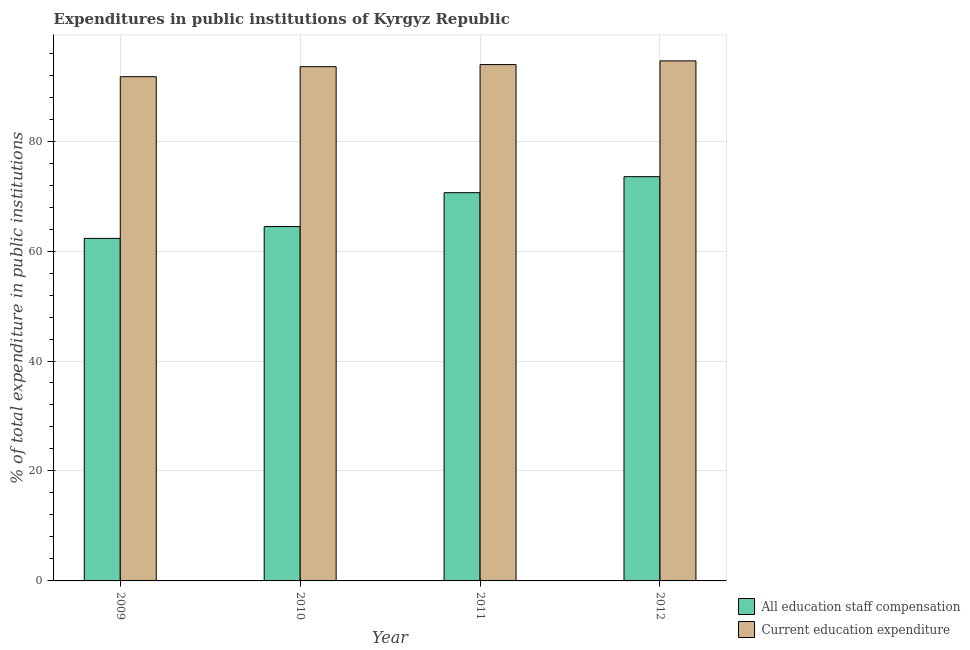How many different coloured bars are there?
Your answer should be compact. 2. Are the number of bars per tick equal to the number of legend labels?
Your answer should be compact. Yes. Are the number of bars on each tick of the X-axis equal?
Your answer should be compact. Yes. How many bars are there on the 2nd tick from the left?
Give a very brief answer. 2. What is the label of the 3rd group of bars from the left?
Offer a very short reply. 2011. What is the expenditure in education in 2010?
Offer a very short reply. 93.53. Across all years, what is the maximum expenditure in staff compensation?
Make the answer very short. 73.53. Across all years, what is the minimum expenditure in education?
Offer a terse response. 91.71. In which year was the expenditure in education maximum?
Give a very brief answer. 2012. What is the total expenditure in education in the graph?
Your answer should be very brief. 373.75. What is the difference between the expenditure in staff compensation in 2009 and that in 2010?
Offer a terse response. -2.15. What is the difference between the expenditure in education in 2011 and the expenditure in staff compensation in 2010?
Your response must be concise. 0.38. What is the average expenditure in education per year?
Provide a short and direct response. 93.44. In the year 2009, what is the difference between the expenditure in staff compensation and expenditure in education?
Keep it short and to the point. 0. In how many years, is the expenditure in education greater than 68 %?
Your answer should be compact. 4. What is the ratio of the expenditure in education in 2010 to that in 2011?
Provide a short and direct response. 1. Is the expenditure in staff compensation in 2009 less than that in 2010?
Make the answer very short. Yes. What is the difference between the highest and the second highest expenditure in staff compensation?
Your response must be concise. 2.91. What is the difference between the highest and the lowest expenditure in staff compensation?
Your response must be concise. 11.22. In how many years, is the expenditure in education greater than the average expenditure in education taken over all years?
Give a very brief answer. 3. Is the sum of the expenditure in education in 2011 and 2012 greater than the maximum expenditure in staff compensation across all years?
Provide a short and direct response. Yes. What does the 1st bar from the left in 2010 represents?
Ensure brevity in your answer.  All education staff compensation. What does the 1st bar from the right in 2009 represents?
Make the answer very short. Current education expenditure. What is the difference between two consecutive major ticks on the Y-axis?
Provide a short and direct response. 20. Does the graph contain grids?
Keep it short and to the point. Yes. How are the legend labels stacked?
Give a very brief answer. Vertical. What is the title of the graph?
Offer a terse response. Expenditures in public institutions of Kyrgyz Republic. Does "Merchandise imports" appear as one of the legend labels in the graph?
Your answer should be compact. No. What is the label or title of the Y-axis?
Offer a very short reply. % of total expenditure in public institutions. What is the % of total expenditure in public institutions of All education staff compensation in 2009?
Offer a very short reply. 62.3. What is the % of total expenditure in public institutions in Current education expenditure in 2009?
Your answer should be very brief. 91.71. What is the % of total expenditure in public institutions of All education staff compensation in 2010?
Ensure brevity in your answer.  64.46. What is the % of total expenditure in public institutions of Current education expenditure in 2010?
Your response must be concise. 93.53. What is the % of total expenditure in public institutions of All education staff compensation in 2011?
Ensure brevity in your answer.  70.61. What is the % of total expenditure in public institutions of Current education expenditure in 2011?
Your response must be concise. 93.92. What is the % of total expenditure in public institutions of All education staff compensation in 2012?
Make the answer very short. 73.53. What is the % of total expenditure in public institutions of Current education expenditure in 2012?
Keep it short and to the point. 94.59. Across all years, what is the maximum % of total expenditure in public institutions in All education staff compensation?
Make the answer very short. 73.53. Across all years, what is the maximum % of total expenditure in public institutions in Current education expenditure?
Offer a terse response. 94.59. Across all years, what is the minimum % of total expenditure in public institutions in All education staff compensation?
Your answer should be very brief. 62.3. Across all years, what is the minimum % of total expenditure in public institutions of Current education expenditure?
Provide a succinct answer. 91.71. What is the total % of total expenditure in public institutions in All education staff compensation in the graph?
Make the answer very short. 270.9. What is the total % of total expenditure in public institutions in Current education expenditure in the graph?
Provide a succinct answer. 373.75. What is the difference between the % of total expenditure in public institutions of All education staff compensation in 2009 and that in 2010?
Offer a terse response. -2.15. What is the difference between the % of total expenditure in public institutions of Current education expenditure in 2009 and that in 2010?
Give a very brief answer. -1.82. What is the difference between the % of total expenditure in public institutions of All education staff compensation in 2009 and that in 2011?
Provide a succinct answer. -8.31. What is the difference between the % of total expenditure in public institutions of Current education expenditure in 2009 and that in 2011?
Your answer should be compact. -2.2. What is the difference between the % of total expenditure in public institutions in All education staff compensation in 2009 and that in 2012?
Your answer should be compact. -11.22. What is the difference between the % of total expenditure in public institutions in Current education expenditure in 2009 and that in 2012?
Ensure brevity in your answer.  -2.88. What is the difference between the % of total expenditure in public institutions of All education staff compensation in 2010 and that in 2011?
Your response must be concise. -6.16. What is the difference between the % of total expenditure in public institutions in Current education expenditure in 2010 and that in 2011?
Ensure brevity in your answer.  -0.38. What is the difference between the % of total expenditure in public institutions of All education staff compensation in 2010 and that in 2012?
Your answer should be compact. -9.07. What is the difference between the % of total expenditure in public institutions of Current education expenditure in 2010 and that in 2012?
Make the answer very short. -1.06. What is the difference between the % of total expenditure in public institutions of All education staff compensation in 2011 and that in 2012?
Provide a short and direct response. -2.91. What is the difference between the % of total expenditure in public institutions of Current education expenditure in 2011 and that in 2012?
Ensure brevity in your answer.  -0.67. What is the difference between the % of total expenditure in public institutions of All education staff compensation in 2009 and the % of total expenditure in public institutions of Current education expenditure in 2010?
Keep it short and to the point. -31.23. What is the difference between the % of total expenditure in public institutions in All education staff compensation in 2009 and the % of total expenditure in public institutions in Current education expenditure in 2011?
Your answer should be very brief. -31.61. What is the difference between the % of total expenditure in public institutions in All education staff compensation in 2009 and the % of total expenditure in public institutions in Current education expenditure in 2012?
Keep it short and to the point. -32.29. What is the difference between the % of total expenditure in public institutions of All education staff compensation in 2010 and the % of total expenditure in public institutions of Current education expenditure in 2011?
Offer a terse response. -29.46. What is the difference between the % of total expenditure in public institutions in All education staff compensation in 2010 and the % of total expenditure in public institutions in Current education expenditure in 2012?
Make the answer very short. -30.13. What is the difference between the % of total expenditure in public institutions of All education staff compensation in 2011 and the % of total expenditure in public institutions of Current education expenditure in 2012?
Your response must be concise. -23.98. What is the average % of total expenditure in public institutions of All education staff compensation per year?
Your answer should be very brief. 67.73. What is the average % of total expenditure in public institutions of Current education expenditure per year?
Provide a succinct answer. 93.44. In the year 2009, what is the difference between the % of total expenditure in public institutions in All education staff compensation and % of total expenditure in public institutions in Current education expenditure?
Your response must be concise. -29.41. In the year 2010, what is the difference between the % of total expenditure in public institutions of All education staff compensation and % of total expenditure in public institutions of Current education expenditure?
Offer a very short reply. -29.08. In the year 2011, what is the difference between the % of total expenditure in public institutions in All education staff compensation and % of total expenditure in public institutions in Current education expenditure?
Keep it short and to the point. -23.3. In the year 2012, what is the difference between the % of total expenditure in public institutions in All education staff compensation and % of total expenditure in public institutions in Current education expenditure?
Provide a succinct answer. -21.06. What is the ratio of the % of total expenditure in public institutions in All education staff compensation in 2009 to that in 2010?
Provide a short and direct response. 0.97. What is the ratio of the % of total expenditure in public institutions in Current education expenditure in 2009 to that in 2010?
Offer a terse response. 0.98. What is the ratio of the % of total expenditure in public institutions in All education staff compensation in 2009 to that in 2011?
Offer a terse response. 0.88. What is the ratio of the % of total expenditure in public institutions in Current education expenditure in 2009 to that in 2011?
Make the answer very short. 0.98. What is the ratio of the % of total expenditure in public institutions of All education staff compensation in 2009 to that in 2012?
Provide a succinct answer. 0.85. What is the ratio of the % of total expenditure in public institutions in Current education expenditure in 2009 to that in 2012?
Your answer should be very brief. 0.97. What is the ratio of the % of total expenditure in public institutions of All education staff compensation in 2010 to that in 2011?
Provide a succinct answer. 0.91. What is the ratio of the % of total expenditure in public institutions of All education staff compensation in 2010 to that in 2012?
Your answer should be very brief. 0.88. What is the ratio of the % of total expenditure in public institutions in All education staff compensation in 2011 to that in 2012?
Provide a short and direct response. 0.96. What is the ratio of the % of total expenditure in public institutions of Current education expenditure in 2011 to that in 2012?
Make the answer very short. 0.99. What is the difference between the highest and the second highest % of total expenditure in public institutions of All education staff compensation?
Offer a very short reply. 2.91. What is the difference between the highest and the second highest % of total expenditure in public institutions of Current education expenditure?
Your answer should be very brief. 0.67. What is the difference between the highest and the lowest % of total expenditure in public institutions of All education staff compensation?
Provide a short and direct response. 11.22. What is the difference between the highest and the lowest % of total expenditure in public institutions in Current education expenditure?
Make the answer very short. 2.88. 